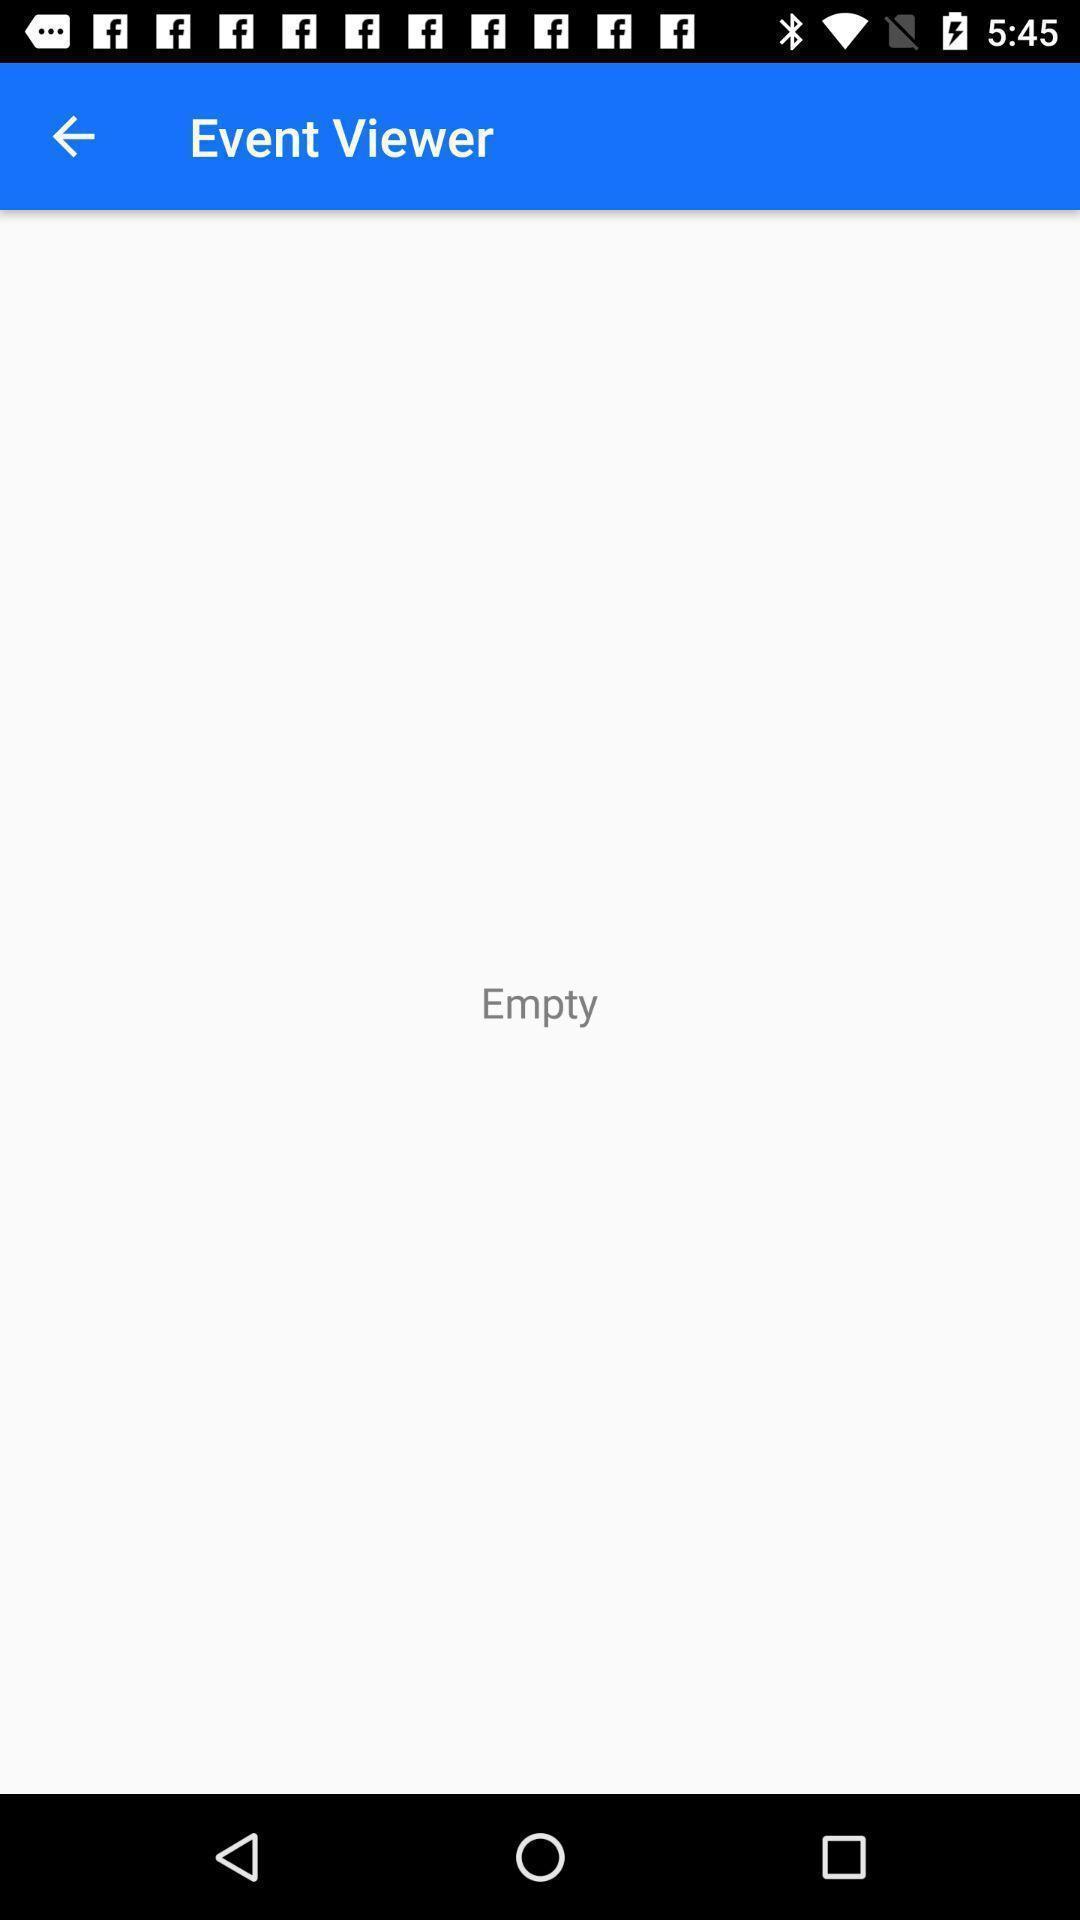Please provide a description for this image. Screen shows an empty event viewer. 